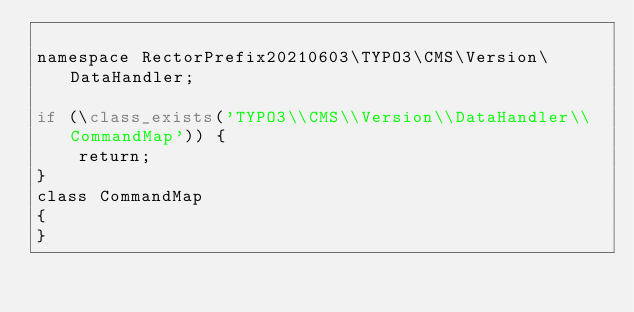Convert code to text. <code><loc_0><loc_0><loc_500><loc_500><_PHP_>
namespace RectorPrefix20210603\TYPO3\CMS\Version\DataHandler;

if (\class_exists('TYPO3\\CMS\\Version\\DataHandler\\CommandMap')) {
    return;
}
class CommandMap
{
}
</code> 